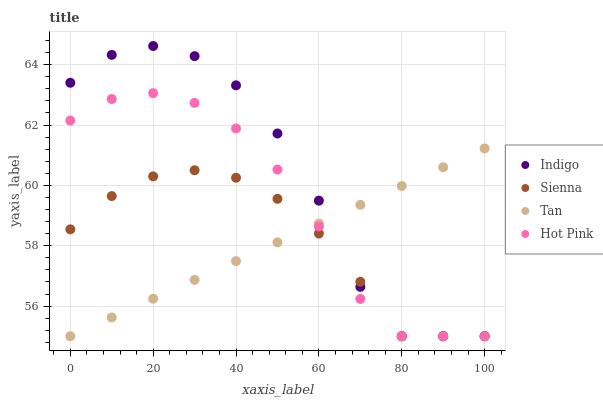Does Tan have the minimum area under the curve?
Answer yes or no. Yes. Does Indigo have the maximum area under the curve?
Answer yes or no. Yes. Does Hot Pink have the minimum area under the curve?
Answer yes or no. No. Does Hot Pink have the maximum area under the curve?
Answer yes or no. No. Is Tan the smoothest?
Answer yes or no. Yes. Is Indigo the roughest?
Answer yes or no. Yes. Is Hot Pink the smoothest?
Answer yes or no. No. Is Hot Pink the roughest?
Answer yes or no. No. Does Sienna have the lowest value?
Answer yes or no. Yes. Does Indigo have the highest value?
Answer yes or no. Yes. Does Tan have the highest value?
Answer yes or no. No. Does Tan intersect Sienna?
Answer yes or no. Yes. Is Tan less than Sienna?
Answer yes or no. No. Is Tan greater than Sienna?
Answer yes or no. No. 